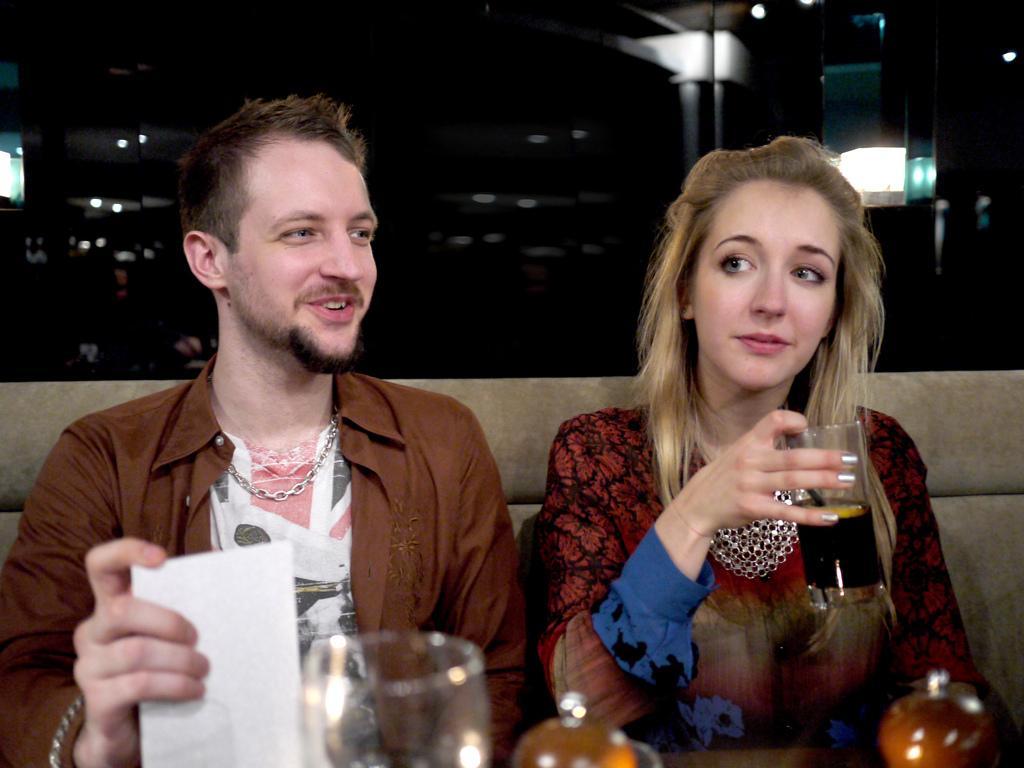Can you describe this image briefly? In this image in the foreground there is one man and one woman who are sitting on a couch, and woman is holding a glass and a man is holding a paper. In front of them there are some glasses and in the background there are some lights, wall and some objects. 